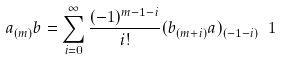<formula> <loc_0><loc_0><loc_500><loc_500>a _ { ( m ) } b = \sum _ { i = 0 } ^ { \infty } \frac { ( - 1 ) ^ { m - 1 - i } } { i ! } ( b _ { ( m + i ) } a ) _ { ( - 1 - i ) } \ 1</formula> 